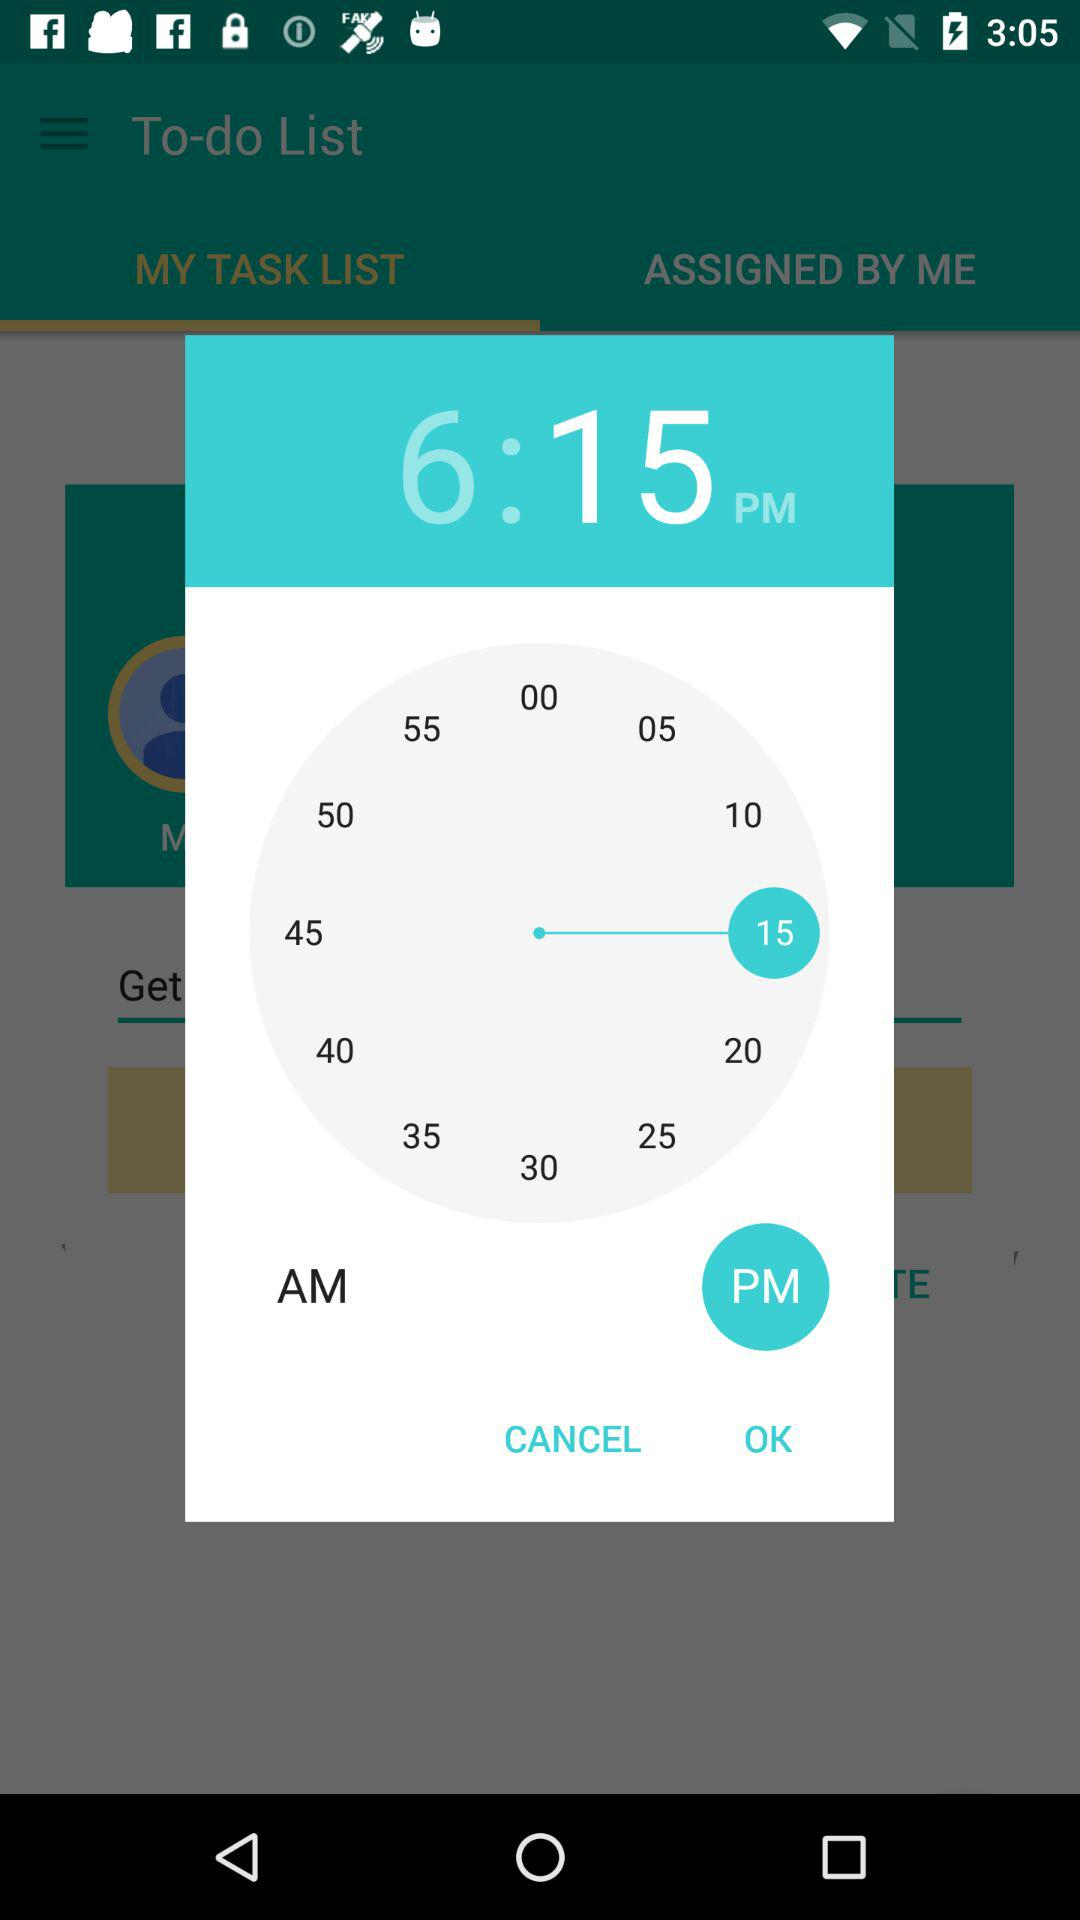How many more minutes are there between 6 and 15 than between 6 and 10?
Answer the question using a single word or phrase. 5 